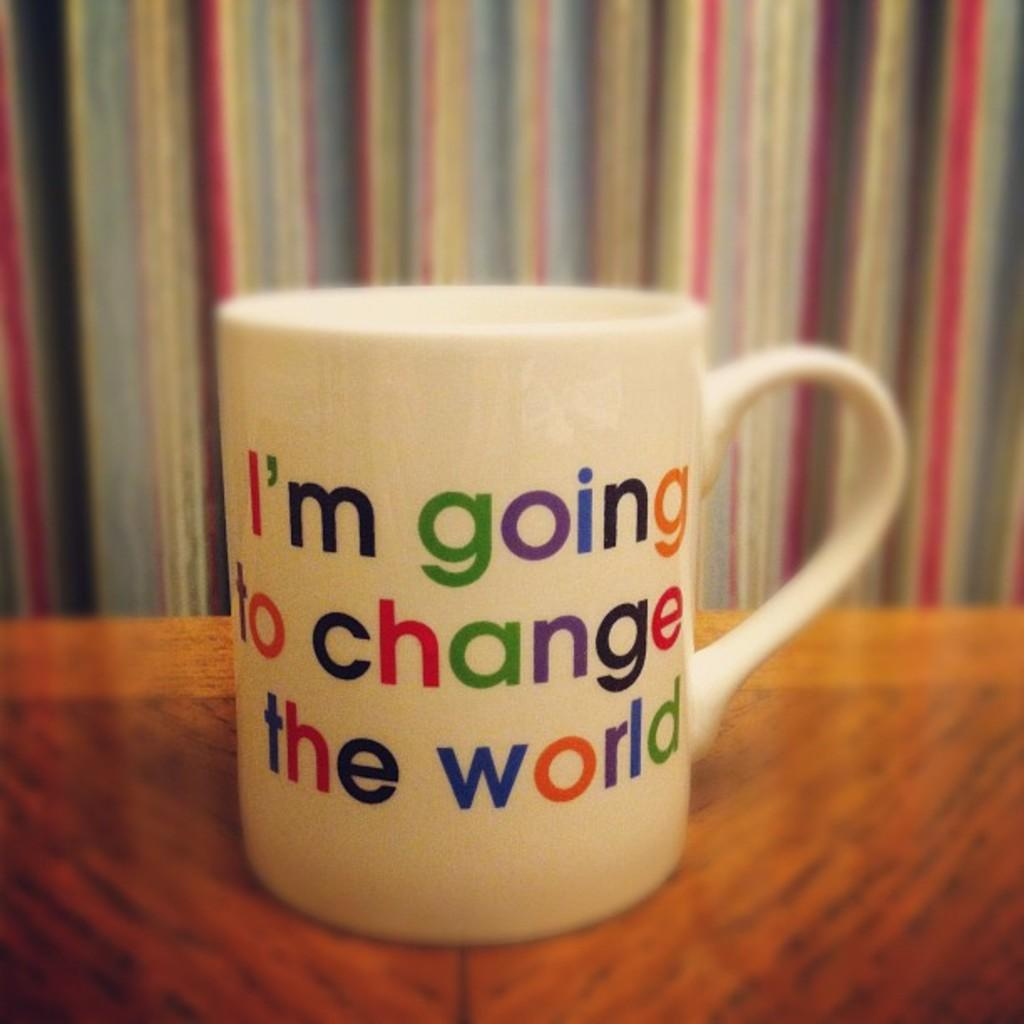<image>
Render a clear and concise summary of the photo. A white mug with colorful writing on it says, "I'm going to change the world". 